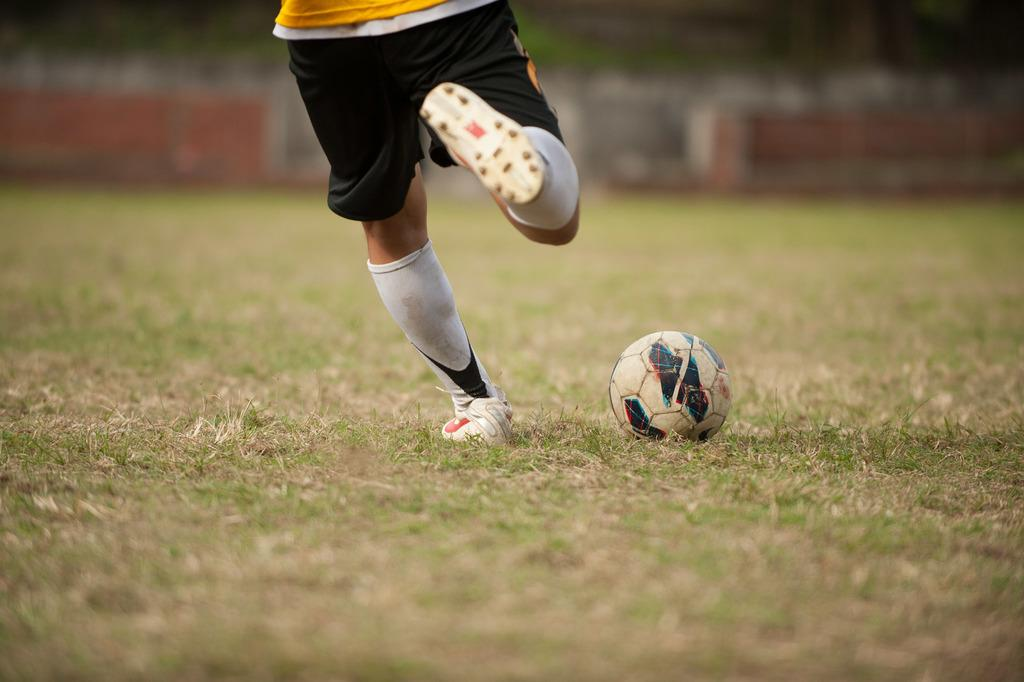What is present in the image along with the person? There is a ball in the image along with the person. What type of surface are the person and the ball situated on? The person and the ball are on the grass. Can you describe the background of the image? The background of the image is blurry. How many cars can be seen driving on the grass in the image? There are no cars present in the image; it features a person and a ball on the grass. What type of flame can be seen in the image? There is no flame present in the image. 